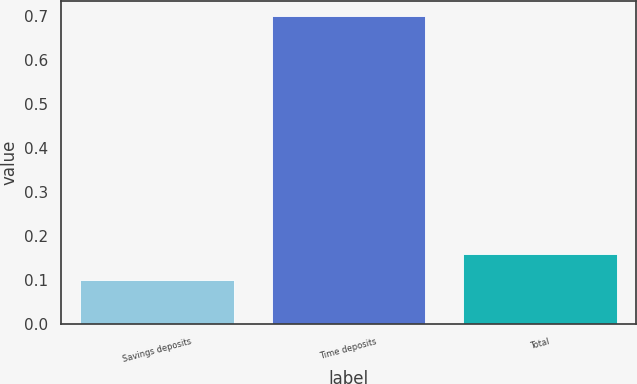<chart> <loc_0><loc_0><loc_500><loc_500><bar_chart><fcel>Savings deposits<fcel>Time deposits<fcel>Total<nl><fcel>0.1<fcel>0.7<fcel>0.16<nl></chart> 